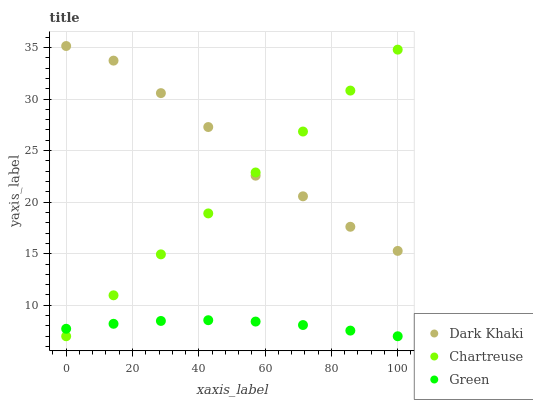Does Green have the minimum area under the curve?
Answer yes or no. Yes. Does Dark Khaki have the maximum area under the curve?
Answer yes or no. Yes. Does Chartreuse have the minimum area under the curve?
Answer yes or no. No. Does Chartreuse have the maximum area under the curve?
Answer yes or no. No. Is Chartreuse the smoothest?
Answer yes or no. Yes. Is Dark Khaki the roughest?
Answer yes or no. Yes. Is Green the smoothest?
Answer yes or no. No. Is Green the roughest?
Answer yes or no. No. Does Chartreuse have the lowest value?
Answer yes or no. Yes. Does Dark Khaki have the highest value?
Answer yes or no. Yes. Does Chartreuse have the highest value?
Answer yes or no. No. Is Green less than Dark Khaki?
Answer yes or no. Yes. Is Dark Khaki greater than Green?
Answer yes or no. Yes. Does Green intersect Chartreuse?
Answer yes or no. Yes. Is Green less than Chartreuse?
Answer yes or no. No. Is Green greater than Chartreuse?
Answer yes or no. No. Does Green intersect Dark Khaki?
Answer yes or no. No. 